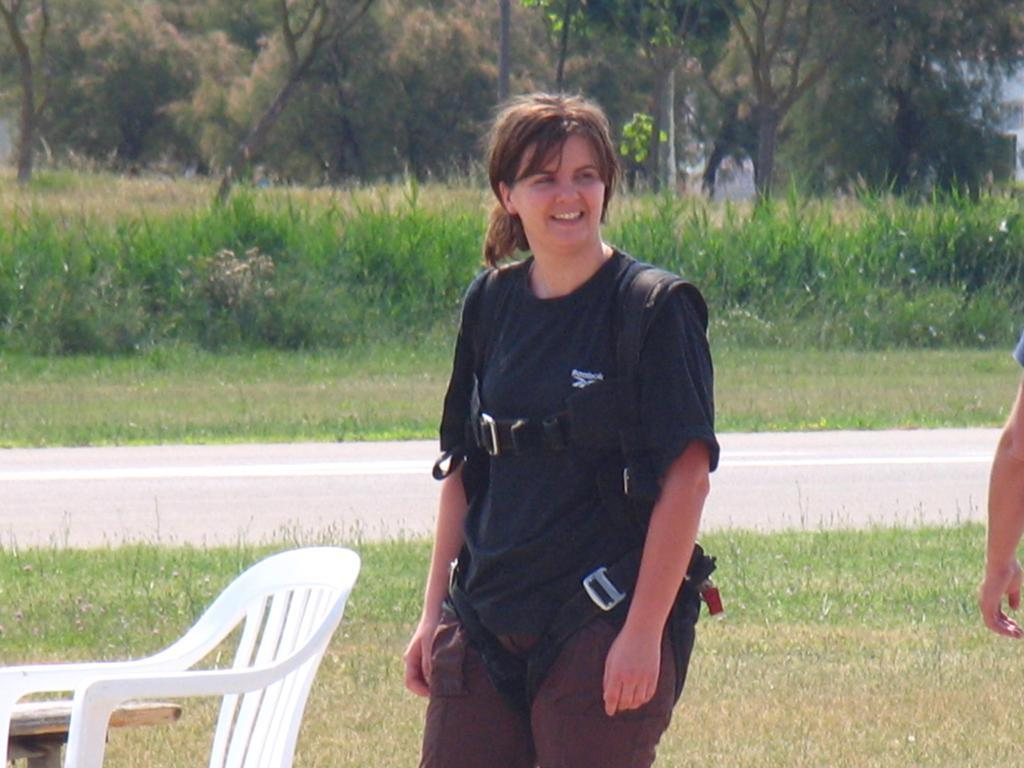Who is present in the image? There is a woman in the image. What piece of furniture is visible in the image? There is a chair in the image. What other piece of furniture is visible in the image? There is a table in the image. What type of natural environment is visible in the image? There is grass and trees visible in the image. What type of polish is the woman applying to the plane in the image? There is no plane present in the image, and therefore no polish or application can be observed. 